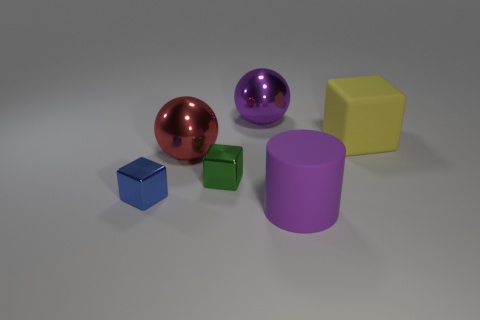Subtract all yellow matte cubes. How many cubes are left? 2 Subtract all red spheres. How many spheres are left? 1 Subtract all cylinders. How many objects are left? 5 Subtract 2 balls. How many balls are left? 0 Add 2 small blue metallic objects. How many objects exist? 8 Subtract all large blue metal blocks. Subtract all small metal objects. How many objects are left? 4 Add 6 purple matte cylinders. How many purple matte cylinders are left? 7 Add 4 purple rubber blocks. How many purple rubber blocks exist? 4 Subtract 0 purple blocks. How many objects are left? 6 Subtract all brown cylinders. Subtract all brown spheres. How many cylinders are left? 1 